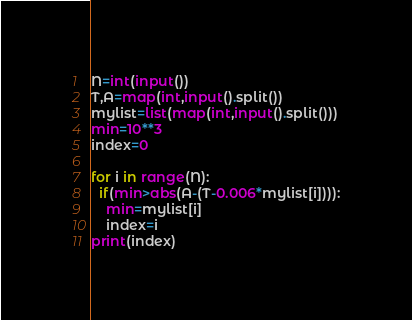Convert code to text. <code><loc_0><loc_0><loc_500><loc_500><_Python_>N=int(input())
T,A=map(int,input().split())
mylist=list(map(int,input().split()))
min=10**3
index=0

for i in range(N):
  if(min>abs(A-(T-0.006*mylist[i]))):
    min=mylist[i]
    index=i
print(index)
</code> 